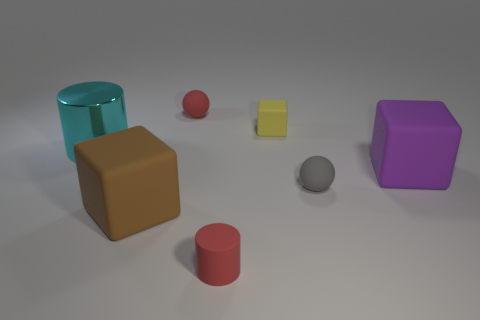Subtract all red cylinders. Subtract all yellow cubes. How many cylinders are left? 1 Add 2 tiny brown balls. How many objects exist? 9 Subtract all cylinders. How many objects are left? 5 Subtract all matte balls. Subtract all tiny blue rubber blocks. How many objects are left? 5 Add 5 small yellow things. How many small yellow things are left? 6 Add 1 red matte things. How many red matte things exist? 3 Subtract 0 green cylinders. How many objects are left? 7 